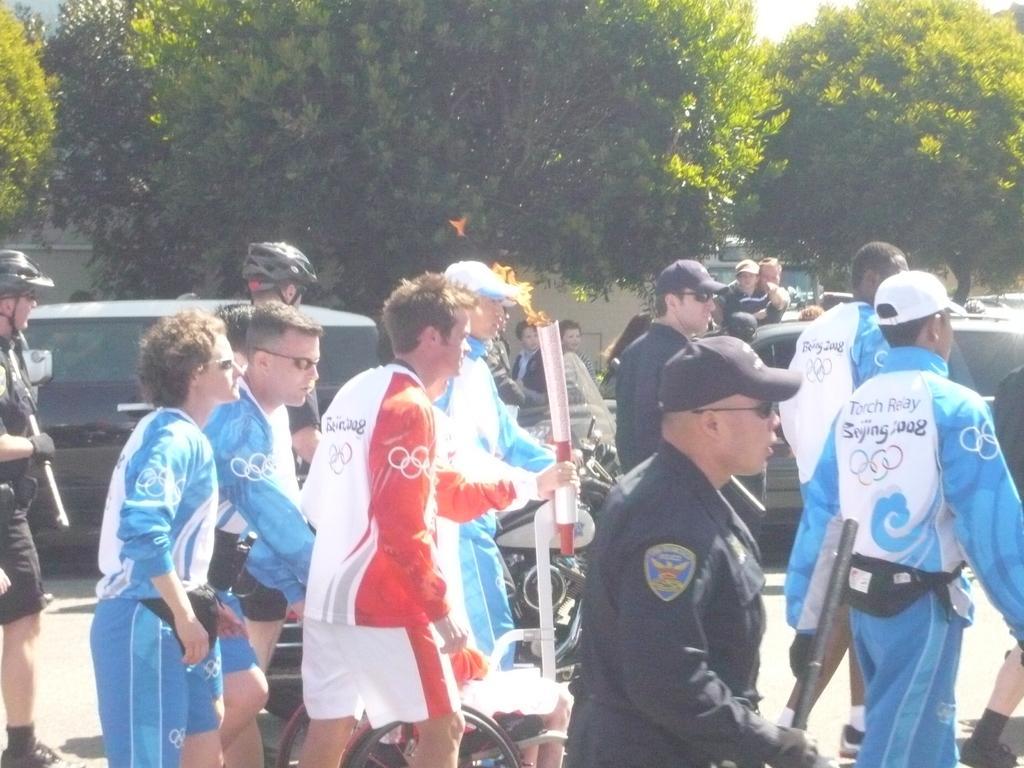How would you summarize this image in a sentence or two? In this picture, we see many people walking on the road. We even see men in black t-shirt who is wearing a black helmet is riding bicycle. Behind that, we see a vehicle in black color. There are many trees and vehicles in the background. It is a sunny day and this picture might be clicked outside the city. 